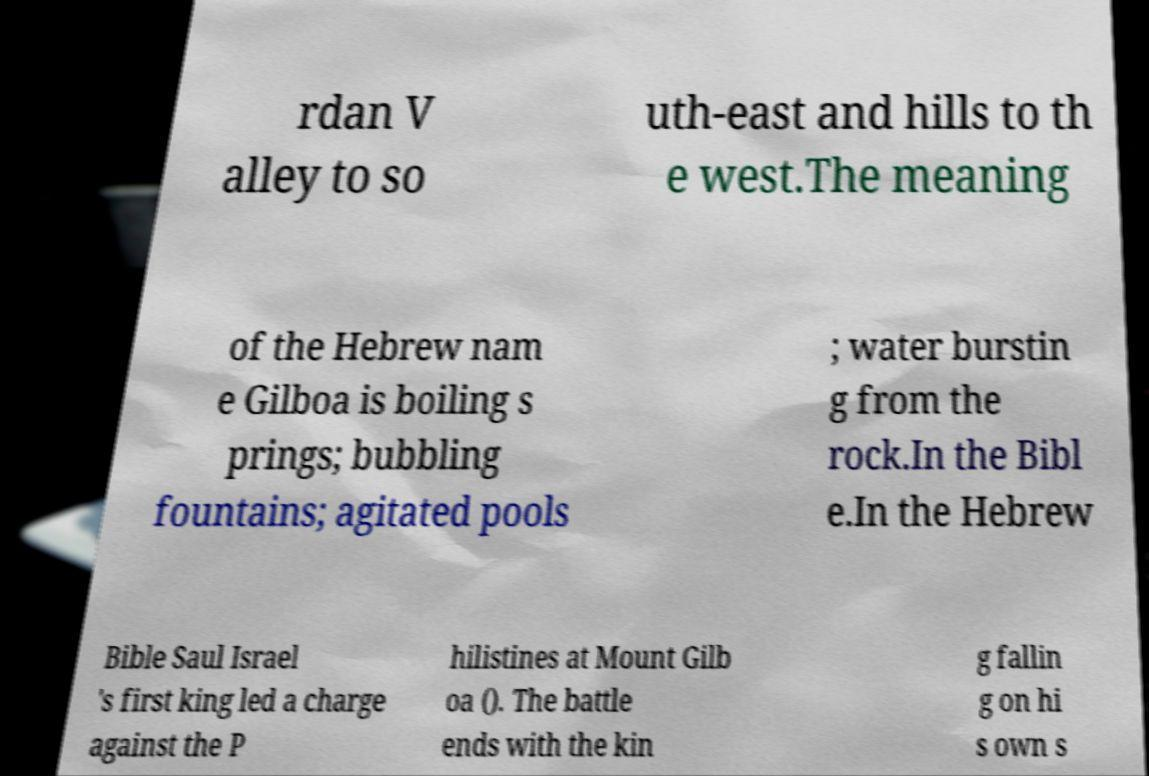I need the written content from this picture converted into text. Can you do that? rdan V alley to so uth-east and hills to th e west.The meaning of the Hebrew nam e Gilboa is boiling s prings; bubbling fountains; agitated pools ; water burstin g from the rock.In the Bibl e.In the Hebrew Bible Saul Israel 's first king led a charge against the P hilistines at Mount Gilb oa (). The battle ends with the kin g fallin g on hi s own s 